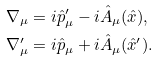<formula> <loc_0><loc_0><loc_500><loc_500>& \nabla _ { \mu } = i \hat { p } _ { \mu } ^ { \prime } - i \hat { A } _ { \mu } ( \hat { x } ) , \\ & \nabla _ { \mu } ^ { \prime } = i \hat { p } _ { \mu } + i \hat { A } _ { \mu } ( \hat { x } ^ { \prime } ) .</formula> 